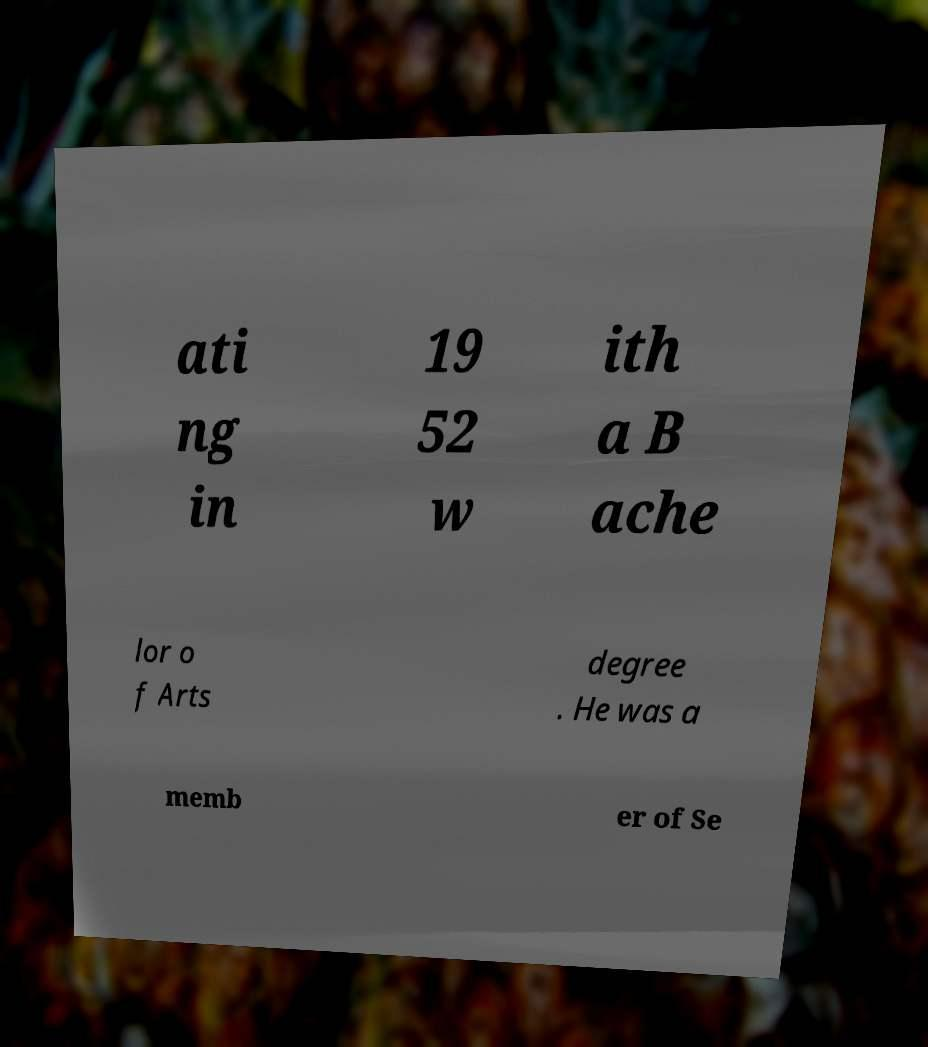Can you read and provide the text displayed in the image?This photo seems to have some interesting text. Can you extract and type it out for me? ati ng in 19 52 w ith a B ache lor o f Arts degree . He was a memb er of Se 